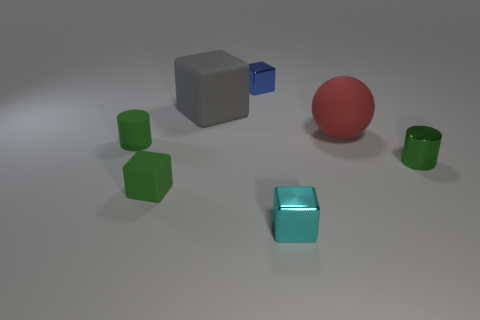Are there more metal objects than large gray things?
Make the answer very short. Yes. Do the red matte thing and the rubber cylinder have the same size?
Keep it short and to the point. No. What number of objects are either small purple shiny cubes or large matte objects?
Make the answer very short. 2. There is a rubber thing that is behind the large thing in front of the large thing that is on the left side of the large red matte sphere; what is its shape?
Make the answer very short. Cube. Are the large thing to the right of the cyan metallic block and the tiny green cylinder that is to the right of the small blue metallic object made of the same material?
Keep it short and to the point. No. There is a blue object that is the same shape as the gray matte object; what material is it?
Offer a terse response. Metal. Are there any other things that have the same size as the cyan metal block?
Ensure brevity in your answer.  Yes. There is a small metallic object that is to the right of the red sphere; does it have the same shape as the tiny rubber thing in front of the small rubber cylinder?
Provide a short and direct response. No. Are there fewer big red balls in front of the big gray thing than small green metallic objects that are left of the tiny green shiny cylinder?
Provide a short and direct response. No. What number of other things are the same shape as the tiny cyan shiny thing?
Make the answer very short. 3. 